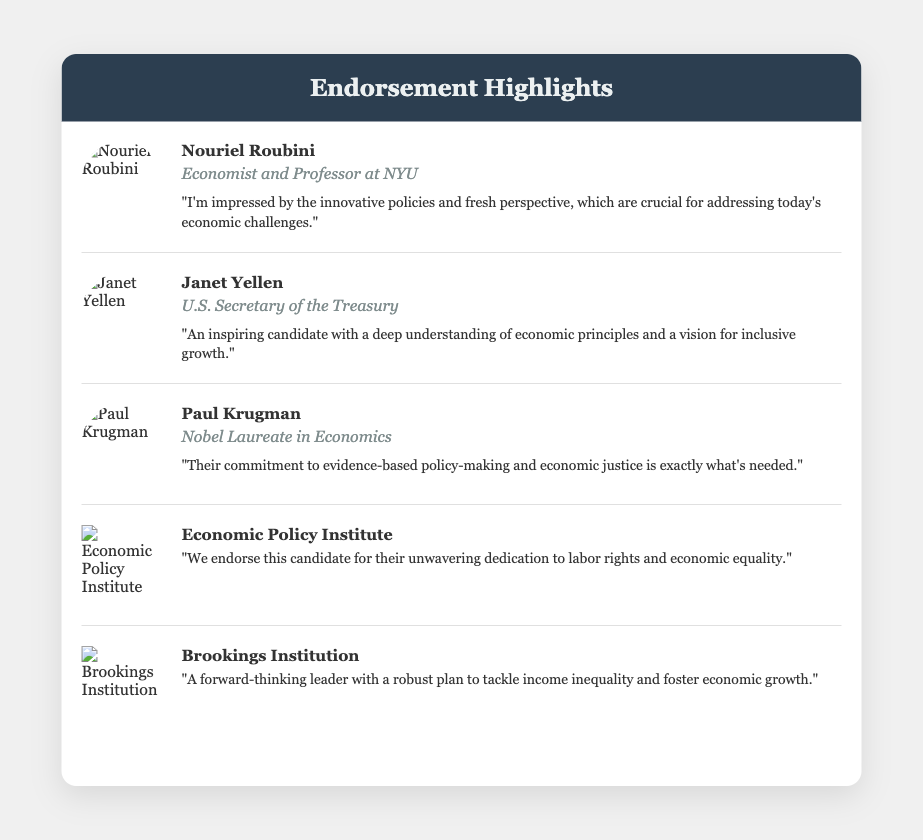What is the title of the document? The title is specified in the <title> tag of the HTML document.
Answer: Endorsement Highlights Who is the first endorser listed? The first endorser is indicated in the first endorsement section of the document.
Answer: Nouriel Roubini What is the position of Janet Yellen? The position is mentioned directly below her name in the endorsement section.
Answer: U.S. Secretary of the Treasury How many endorsements are featured in the document? The number of endorsements can be counted from the endorsements listed.
Answer: Five What is the main focus of the Economic Policy Institute's endorsement? The focus can be determined from the quote provided in their endorsement section.
Answer: Labor rights and economic equality Which endorser is a Nobel Laureate? This information is specified in the endorsement section for that individual.
Answer: Paul Krugman What color is the card’s header? The color is mentioned in the styling of the header section of the document.
Answer: Dark blue What quote is attributed to Paul Krugman? The quote is directly provided in the endorsement section under his name.
Answer: "Their commitment to evidence-based policy-making and economic justice is exactly what's needed." Which organization is associated with a logo endorsement? This can be found in the sections with logo images instead of photos.
Answer: Economic Policy Institute Who is the current header color associated with in the document? The header color can be inferred from the design elements that describe the document.
Answer: Endorsement Highlights 